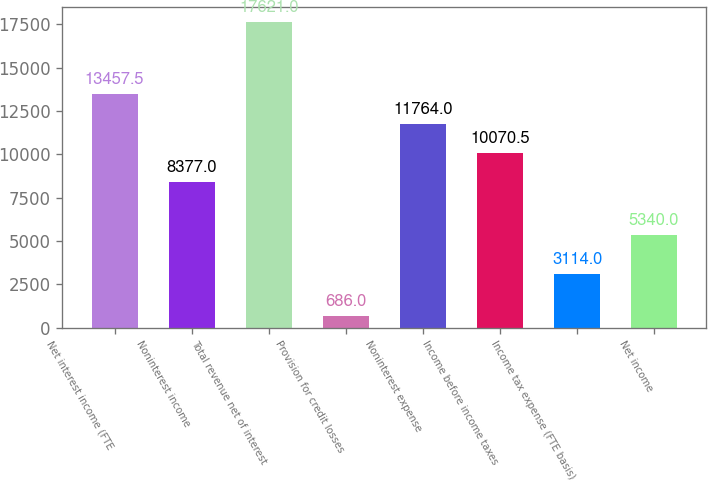Convert chart to OTSL. <chart><loc_0><loc_0><loc_500><loc_500><bar_chart><fcel>Net interest income (FTE<fcel>Noninterest income<fcel>Total revenue net of interest<fcel>Provision for credit losses<fcel>Noninterest expense<fcel>Income before income taxes<fcel>Income tax expense (FTE basis)<fcel>Net income<nl><fcel>13457.5<fcel>8377<fcel>17621<fcel>686<fcel>11764<fcel>10070.5<fcel>3114<fcel>5340<nl></chart> 